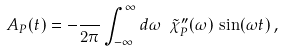<formula> <loc_0><loc_0><loc_500><loc_500>A _ { P } ( t ) = - \frac { } { 2 \pi } \int _ { - \infty } ^ { \infty } d \omega \ \tilde { \chi } _ { P } ^ { \prime \prime } ( \omega ) \, \sin ( \omega t ) \, ,</formula> 